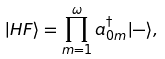Convert formula to latex. <formula><loc_0><loc_0><loc_500><loc_500>| H F \rangle = \prod _ { m = 1 } ^ { \omega } a ^ { \dagger } _ { 0 m } | - \rangle ,</formula> 